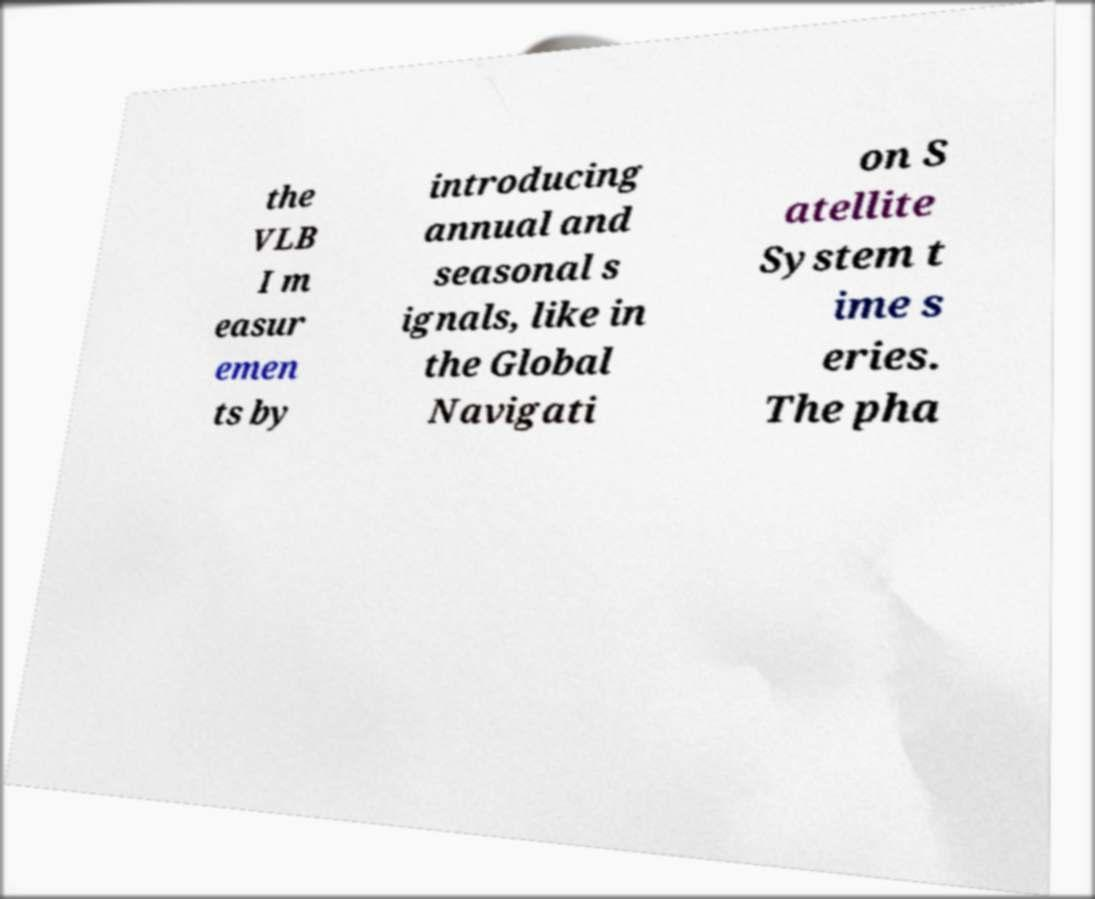Can you read and provide the text displayed in the image?This photo seems to have some interesting text. Can you extract and type it out for me? the VLB I m easur emen ts by introducing annual and seasonal s ignals, like in the Global Navigati on S atellite System t ime s eries. The pha 